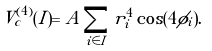<formula> <loc_0><loc_0><loc_500><loc_500>V _ { c } ^ { ( 4 ) } ( I ) = A \sum _ { i \in I } r _ { i } ^ { 4 } \cos ( 4 \phi _ { i } ) .</formula> 